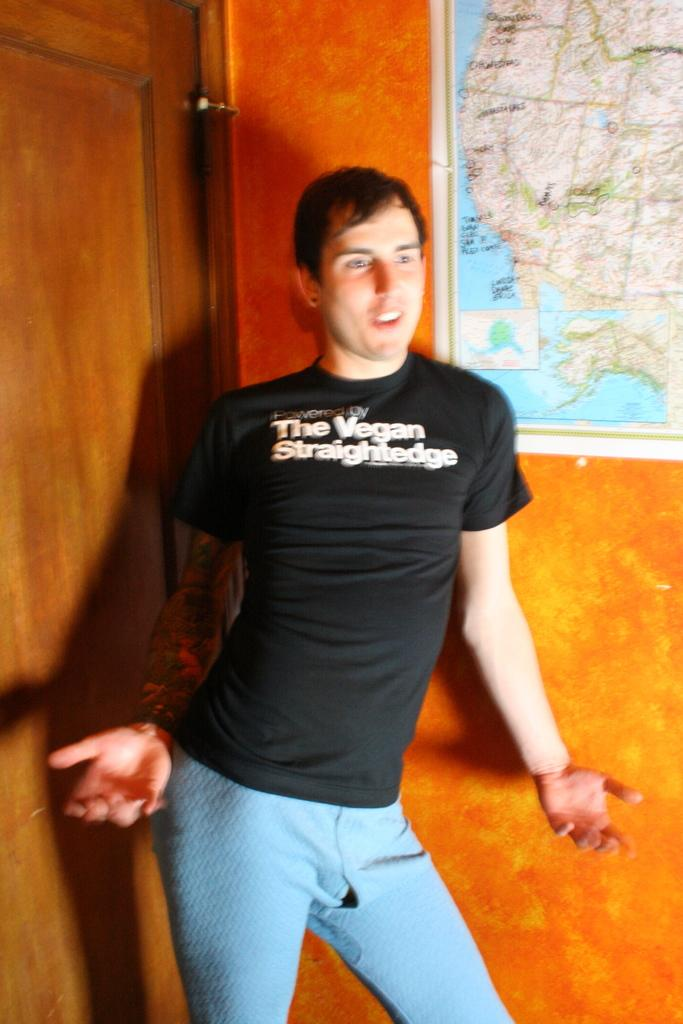Provide a one-sentence caption for the provided image. A man with a black shirt that says "Powered by The Vegan Straightedge". 